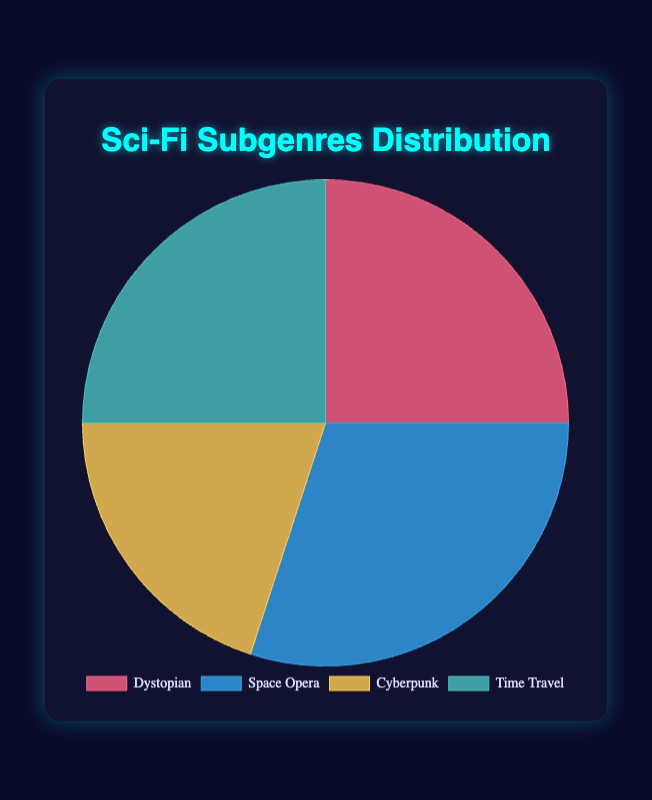What are the two most popular subgenres in the chart? Look at the percentages next to each subgenre. The highest percentages are 30% (Space Opera) and 25% (Dystopian and Time Travel). Since 25% appears twice, those are the top two categories.
Answer: Space Opera and Dystopian, Time Travel Which subgenre has the least percentage share in the distribution? By examining the chart, the subgenre with the smallest percentage is 20%, which corresponds to Cyberpunk.
Answer: Cyberpunk What is the combined percentage of Dystopian and Time Travel subgenres? Add the percentages of Dystopian and Time Travel: 25% + 25% = 50%.
Answer: 50% How does the percentage of Space Opera compare to Cyberpunk? Space Opera has 30% and Cyberpunk has 20%. Comparing these, Space Opera has 10% more.
Answer: Space Opera is 10% higher than Cyberpunk Which color is used to represent the Dystopian subgenre in the chart? Look at the color key in the pie chart. Dystopian is denoted by the section colored in red.
Answer: Red What fraction of the total does the Time Travel subgenre constitute? The chart shows Time Travel at 25%, which is 25/100. Simplified, this fraction is 1/4.
Answer: 1/4 How does the sum of percentages for Space Opera and Cyberpunk compare to that for Dystopian and Time Travel? Space Opera and Cyberpunk = 30% + 20% = 50%. Dystopian and Time Travel = 25% + 25% = 50%. Both sums are equal.
Answer: They are equal What's the total percentage of subgenres aside from Space Opera? Subtract the Space Opera percentage (30%) from the total (100%): 100% - 30% = 70%.
Answer: 70% If another subgenre 'Alien Invasion' were to be added with a percentage equal to half of Cyberpunk, what would be the percentage distribution for Alien Invasion? Cyberpunk is 20%, half of which is 10%.
Answer: 10% How does the representation of subgenres with the same percentage impact the visual balance in a pie chart? Subgenres with identical percentages (like Dystopian and Time Travel at 25%) create visually equal slices, contributing to a balanced look in the chart.
Answer: Equal slices create visual balance 